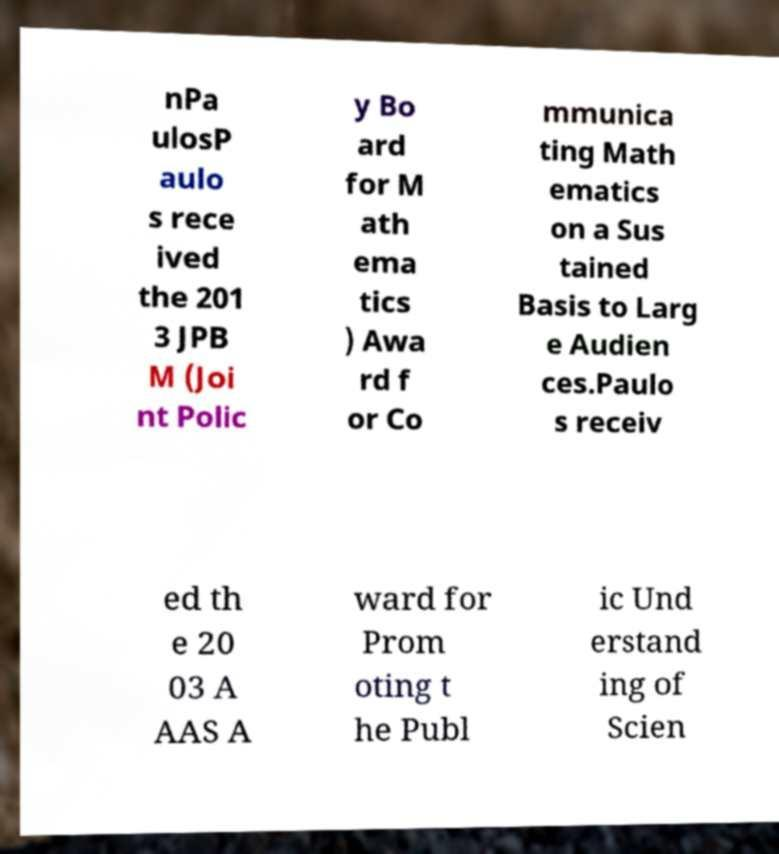There's text embedded in this image that I need extracted. Can you transcribe it verbatim? nPa ulosP aulo s rece ived the 201 3 JPB M (Joi nt Polic y Bo ard for M ath ema tics ) Awa rd f or Co mmunica ting Math ematics on a Sus tained Basis to Larg e Audien ces.Paulo s receiv ed th e 20 03 A AAS A ward for Prom oting t he Publ ic Und erstand ing of Scien 